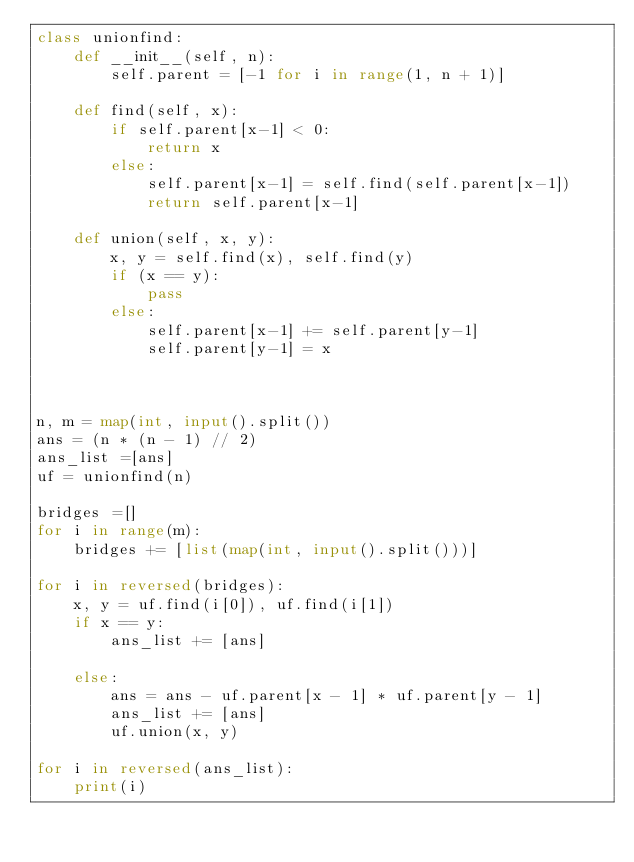<code> <loc_0><loc_0><loc_500><loc_500><_Python_>class unionfind:
    def __init__(self, n):
        self.parent = [-1 for i in range(1, n + 1)]

    def find(self, x):
        if self.parent[x-1] < 0:
            return x
        else:
            self.parent[x-1] = self.find(self.parent[x-1])
            return self.parent[x-1]

    def union(self, x, y):
        x, y = self.find(x), self.find(y)
        if (x == y):
            pass
        else:
            self.parent[x-1] += self.parent[y-1]
            self.parent[y-1] = x



n, m = map(int, input().split())
ans = (n * (n - 1) // 2)
ans_list =[ans]
uf = unionfind(n)

bridges =[]
for i in range(m):
    bridges += [list(map(int, input().split()))]

for i in reversed(bridges):
    x, y = uf.find(i[0]), uf.find(i[1])
    if x == y:
        ans_list += [ans]

    else:
        ans = ans - uf.parent[x - 1] * uf.parent[y - 1]
        ans_list += [ans]
        uf.union(x, y)

for i in reversed(ans_list):
    print(i)</code> 